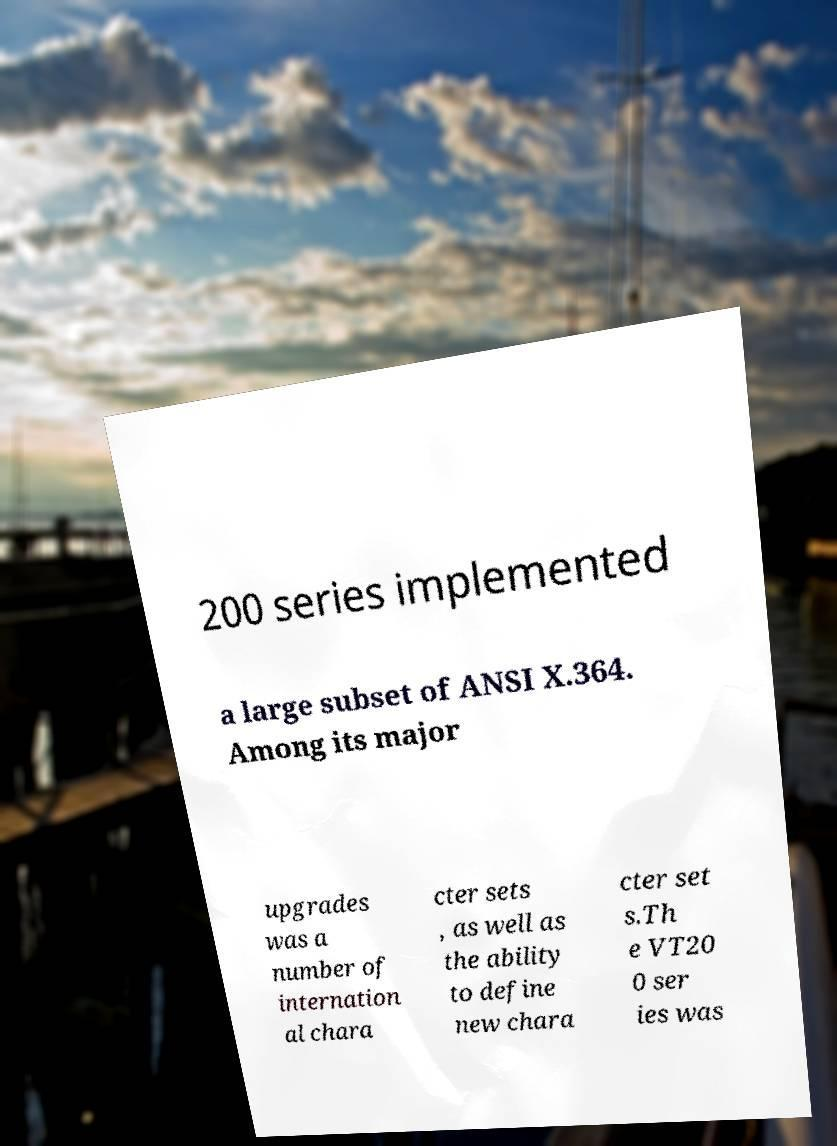Can you accurately transcribe the text from the provided image for me? 200 series implemented a large subset of ANSI X.364. Among its major upgrades was a number of internation al chara cter sets , as well as the ability to define new chara cter set s.Th e VT20 0 ser ies was 